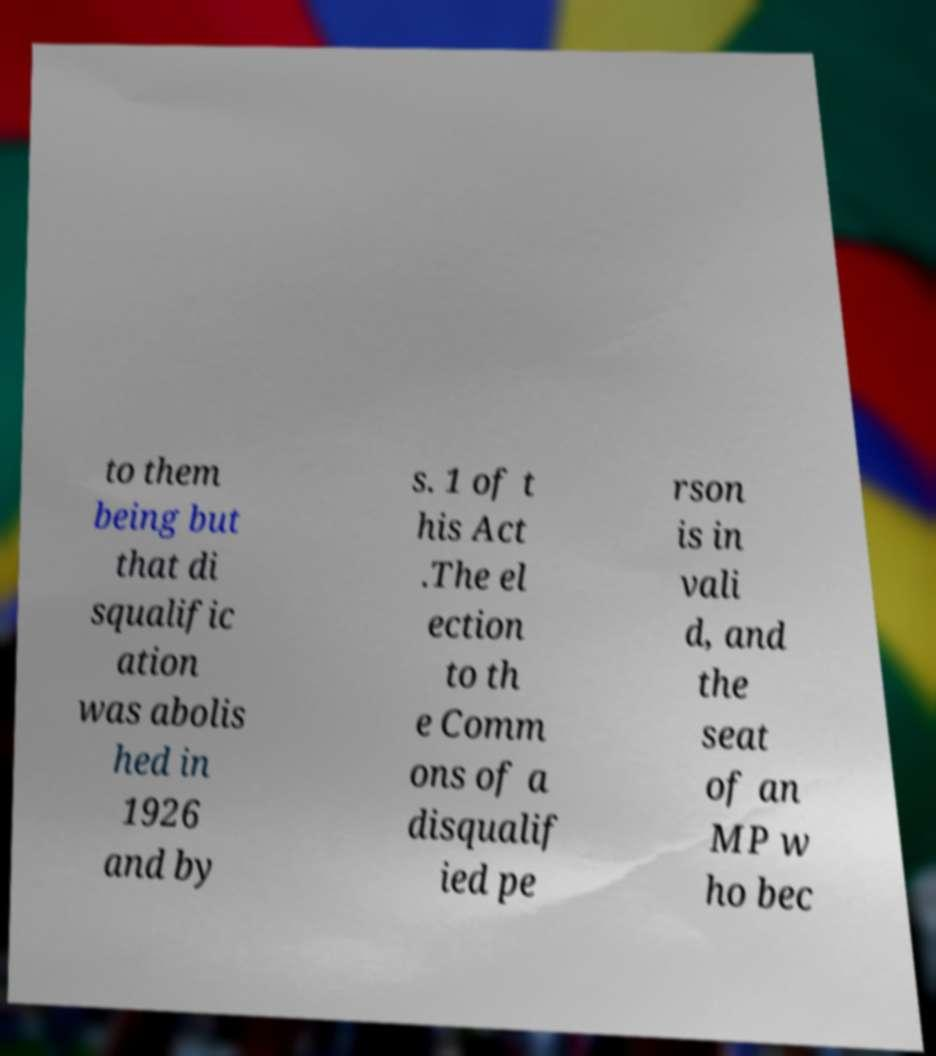Please read and relay the text visible in this image. What does it say? to them being but that di squalific ation was abolis hed in 1926 and by s. 1 of t his Act .The el ection to th e Comm ons of a disqualif ied pe rson is in vali d, and the seat of an MP w ho bec 